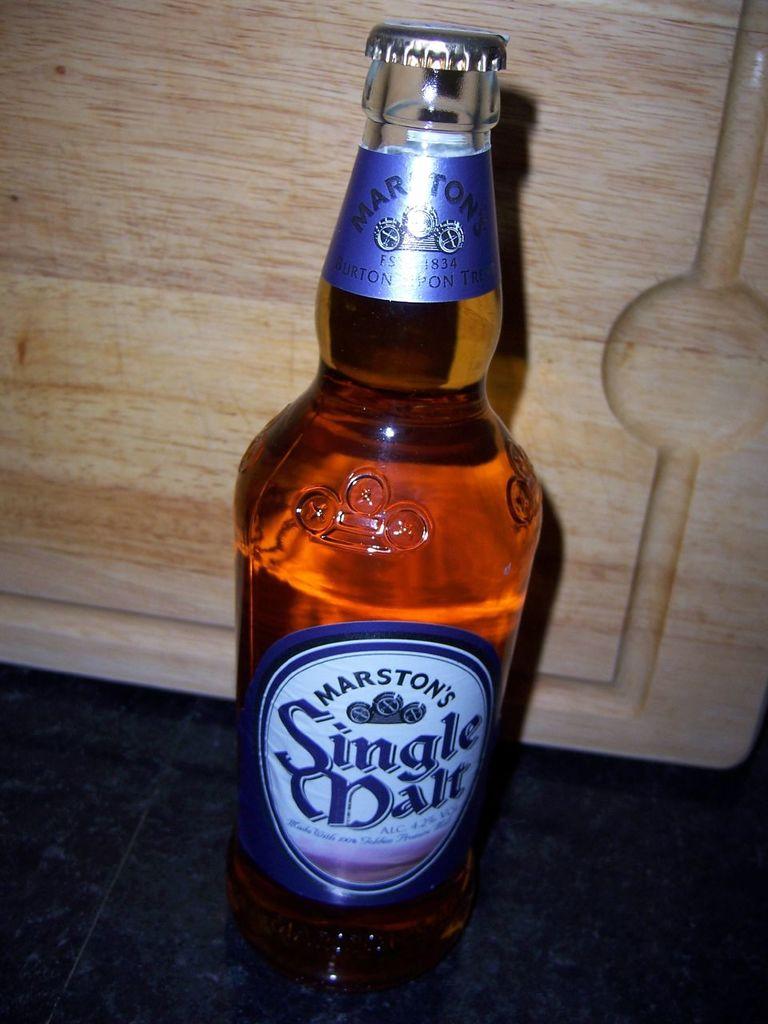What is the brand of the beverage?
Your answer should be very brief. Marston's. How many malt?
Offer a terse response. Single. 